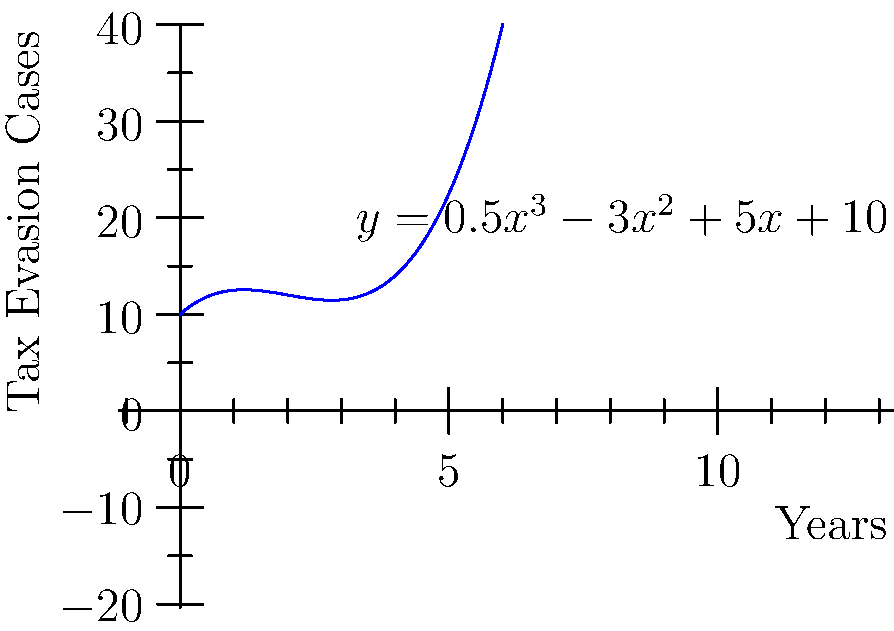As a criminal defense lawyer specializing in tax evasion cases, you're analyzing a trend in tax evasion incidents over time. The polynomial function $y = 0.5x^3 - 3x^2 + 5x + 10$ models the number of tax evasion cases (y) over years (x). At what point in time does the model predict a local minimum number of tax evasion cases? To find the local minimum, we need to follow these steps:

1) Find the derivative of the function:
   $\frac{dy}{dx} = 1.5x^2 - 6x + 5$

2) Set the derivative equal to zero to find critical points:
   $1.5x^2 - 6x + 5 = 0$

3) Solve this quadratic equation:
   $a = 1.5$, $b = -6$, $c = 5$
   Using the quadratic formula: $x = \frac{-b \pm \sqrt{b^2 - 4ac}}{2a}$

4) Calculate:
   $x = \frac{6 \pm \sqrt{36 - 30}}{3} = \frac{6 \pm \sqrt{6}}{3}$

5) This gives us two critical points:
   $x_1 = \frac{6 + \sqrt{6}}{3} \approx 2.82$
   $x_2 = \frac{6 - \sqrt{6}}{3} \approx 1.18$

6) To determine which is the minimum, we can use the second derivative test:
   $\frac{d^2y}{dx^2} = 3x - 6$

7) Evaluate the second derivative at $x_2$:
   $3(1.18) - 6 = -2.46 < 0$

Since the second derivative is negative at $x_2$, this point is a local maximum.

Therefore, the local minimum occurs at $x_1 \approx 2.82$ years.
Answer: 2.82 years 